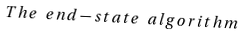<formula> <loc_0><loc_0><loc_500><loc_500>T h e \ e n d - s t a t e \ a l g o r i t h m</formula> 